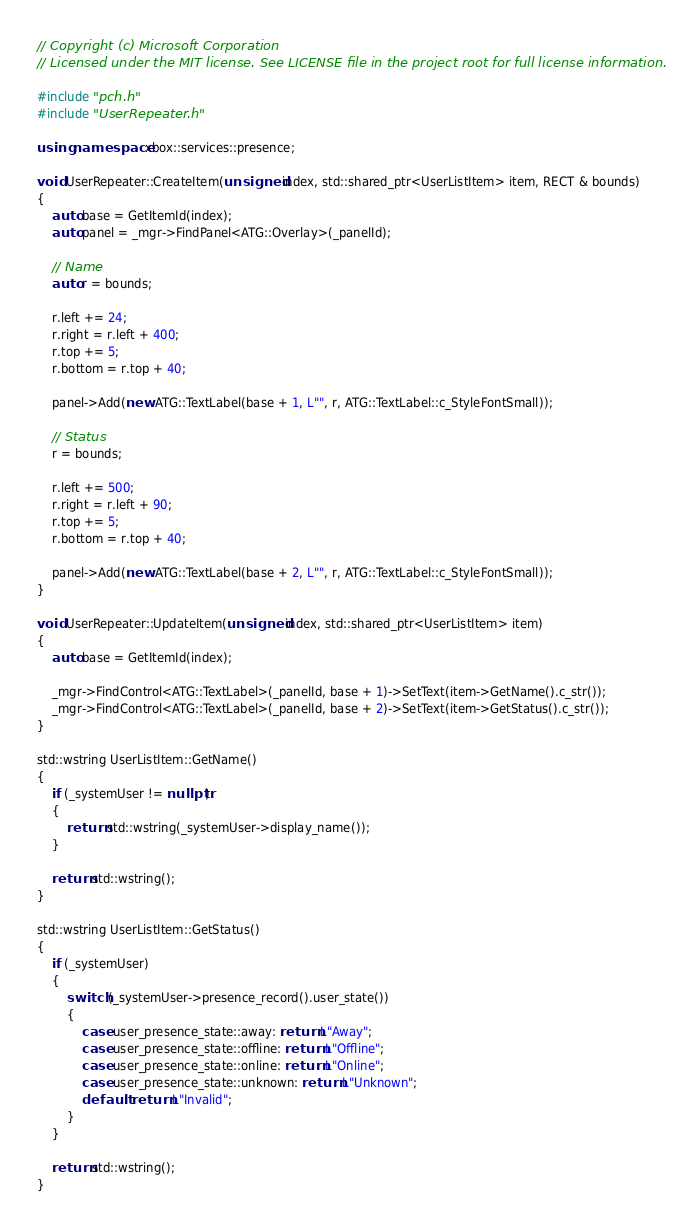<code> <loc_0><loc_0><loc_500><loc_500><_C++_>// Copyright (c) Microsoft Corporation
// Licensed under the MIT license. See LICENSE file in the project root for full license information.

#include "pch.h"
#include "UserRepeater.h"

using namespace xbox::services::presence;

void UserRepeater::CreateItem(unsigned index, std::shared_ptr<UserListItem> item, RECT & bounds)
{
    auto base = GetItemId(index);
    auto panel = _mgr->FindPanel<ATG::Overlay>(_panelId);

    // Name
    auto r = bounds;

    r.left += 24;
    r.right = r.left + 400;
    r.top += 5;
    r.bottom = r.top + 40;

    panel->Add(new ATG::TextLabel(base + 1, L"", r, ATG::TextLabel::c_StyleFontSmall));

    // Status
    r = bounds;

    r.left += 500;
    r.right = r.left + 90;
    r.top += 5;
    r.bottom = r.top + 40;

    panel->Add(new ATG::TextLabel(base + 2, L"", r, ATG::TextLabel::c_StyleFontSmall));
}

void UserRepeater::UpdateItem(unsigned index, std::shared_ptr<UserListItem> item)
{
    auto base = GetItemId(index);

    _mgr->FindControl<ATG::TextLabel>(_panelId, base + 1)->SetText(item->GetName().c_str());
    _mgr->FindControl<ATG::TextLabel>(_panelId, base + 2)->SetText(item->GetStatus().c_str());
}

std::wstring UserListItem::GetName()
{
    if (_systemUser != nullptr)
    {
        return std::wstring(_systemUser->display_name());
    }

    return std::wstring();
}

std::wstring UserListItem::GetStatus()
{
    if (_systemUser)
    {
        switch (_systemUser->presence_record().user_state())
        {
            case user_presence_state::away: return L"Away";
            case user_presence_state::offline: return L"Offline";
            case user_presence_state::online: return L"Online";
            case user_presence_state::unknown: return L"Unknown";
            default: return L"Invalid";
        }
    }

    return std::wstring();
}
</code> 